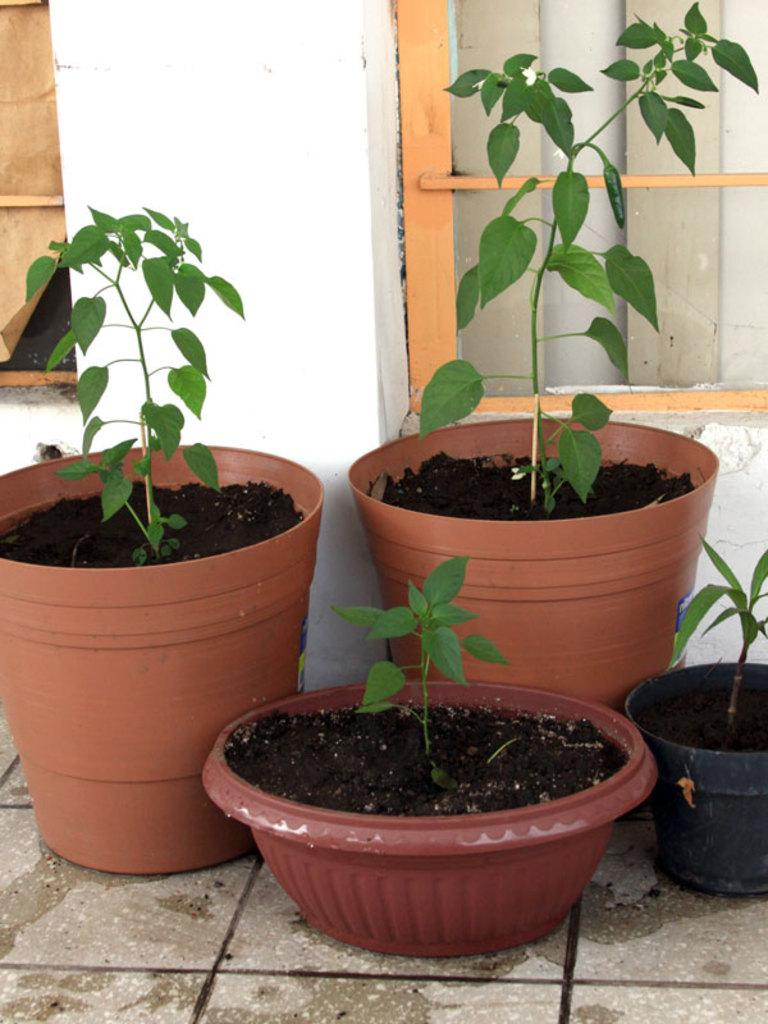What objects are present in the image related to plants? There are flower pots in the image. What can be seen in the background of the image? There are windows and a white color wall in the background of the image. What type of bait is being used to catch fish in the image? There is no bait or fish present in the image; it features flower pots and a background with windows and a white wall. 